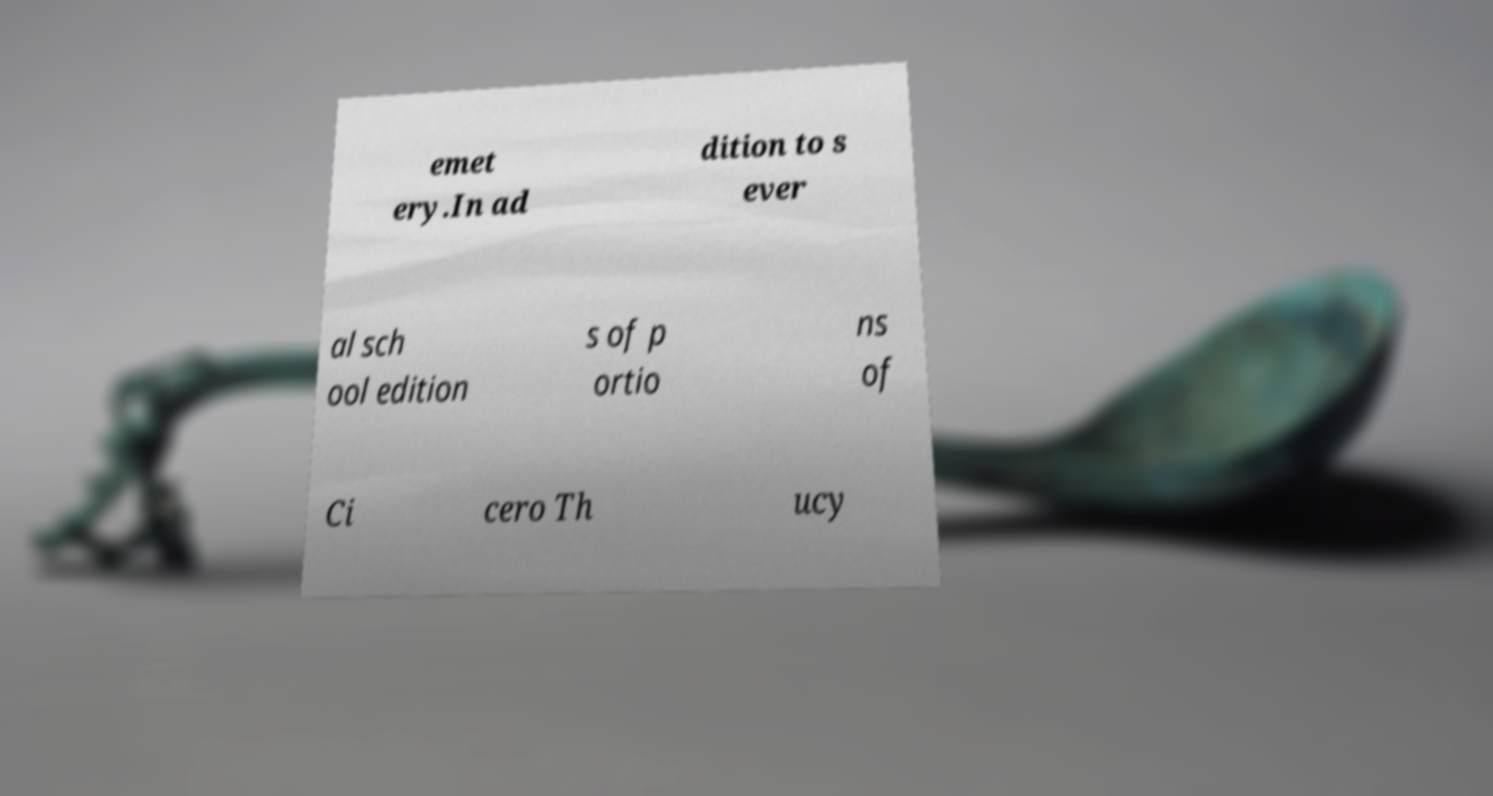Could you extract and type out the text from this image? emet ery.In ad dition to s ever al sch ool edition s of p ortio ns of Ci cero Th ucy 